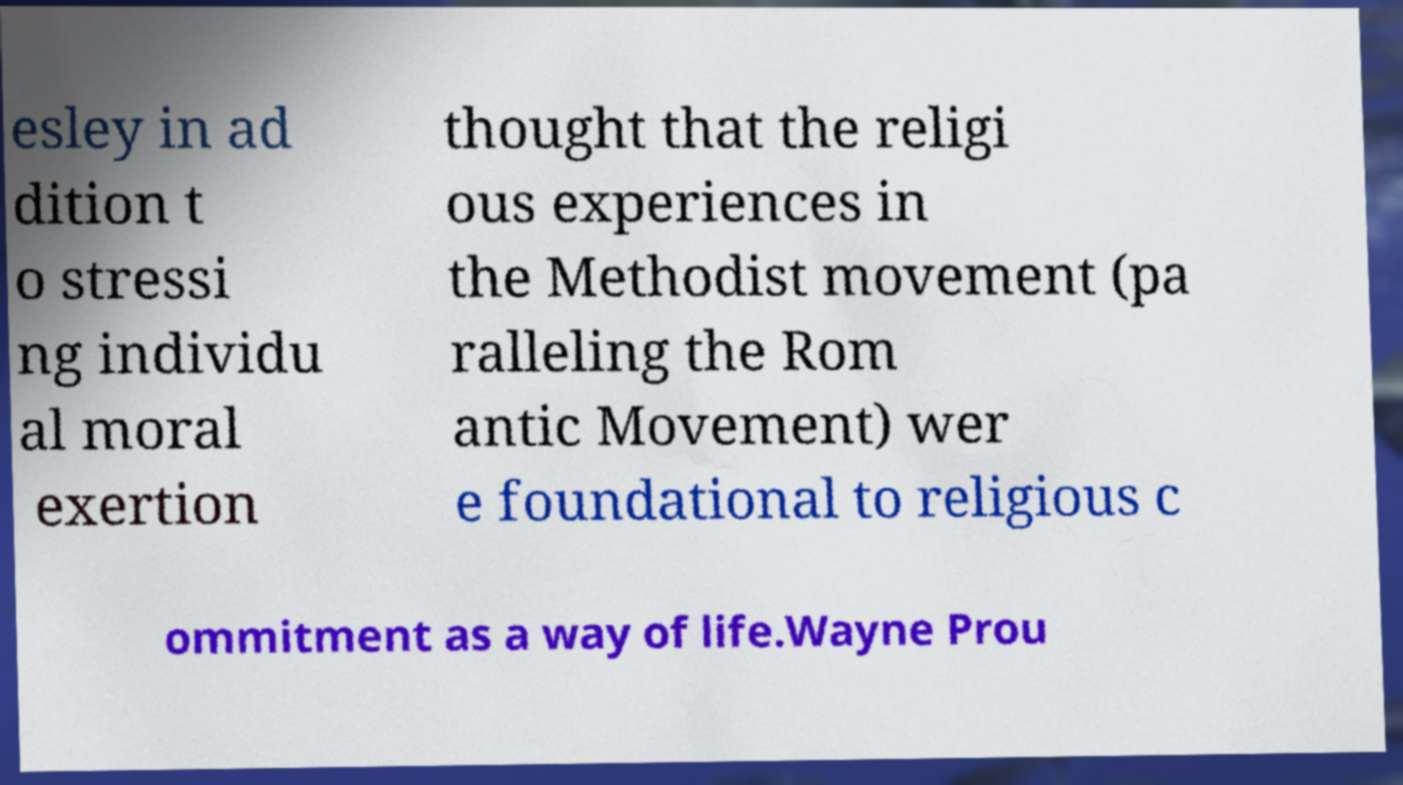Can you accurately transcribe the text from the provided image for me? esley in ad dition t o stressi ng individu al moral exertion thought that the religi ous experiences in the Methodist movement (pa ralleling the Rom antic Movement) wer e foundational to religious c ommitment as a way of life.Wayne Prou 